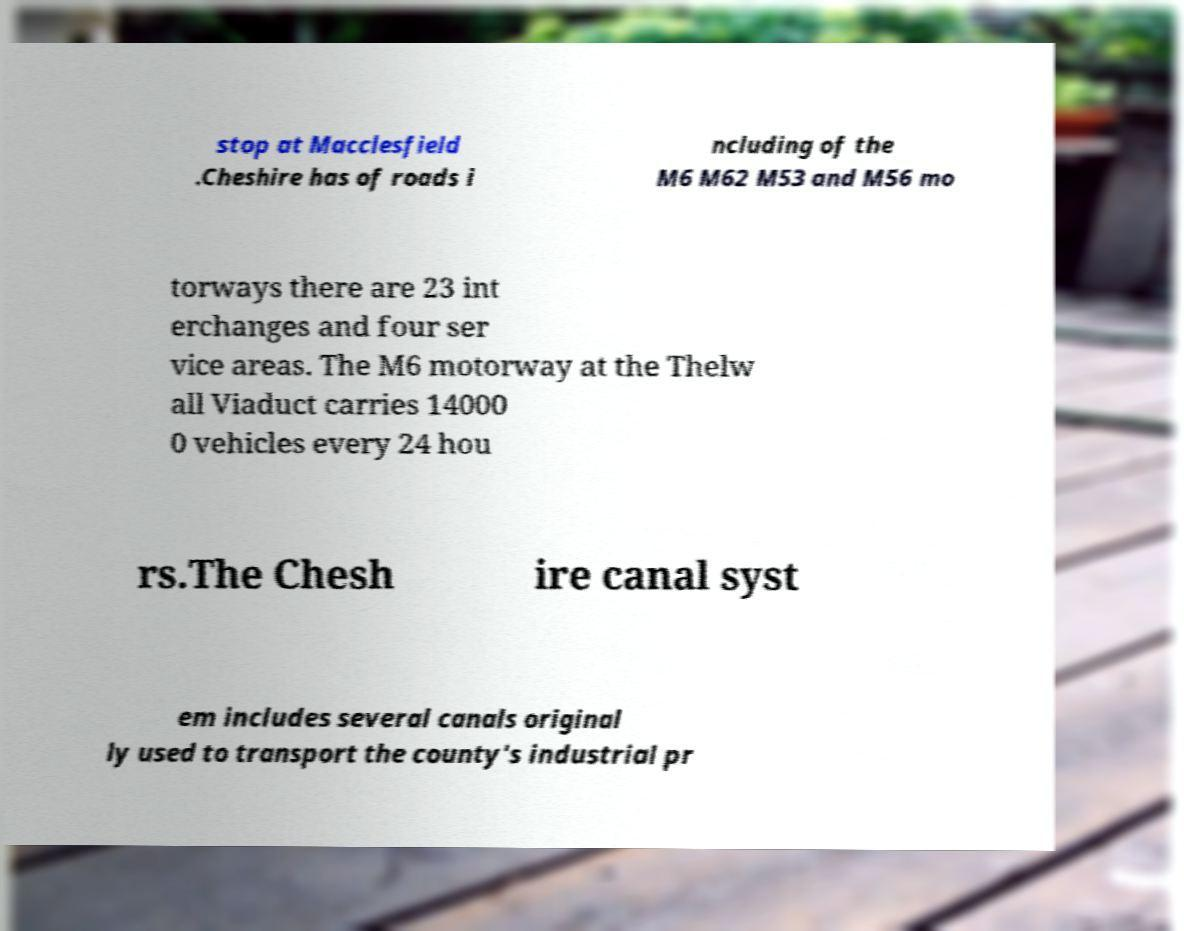Can you accurately transcribe the text from the provided image for me? stop at Macclesfield .Cheshire has of roads i ncluding of the M6 M62 M53 and M56 mo torways there are 23 int erchanges and four ser vice areas. The M6 motorway at the Thelw all Viaduct carries 14000 0 vehicles every 24 hou rs.The Chesh ire canal syst em includes several canals original ly used to transport the county's industrial pr 